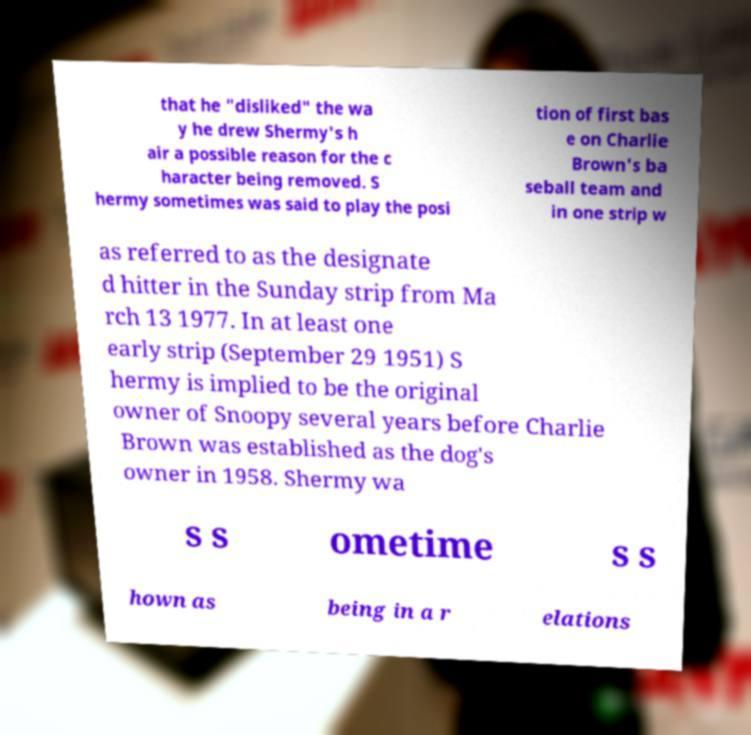There's text embedded in this image that I need extracted. Can you transcribe it verbatim? that he "disliked" the wa y he drew Shermy's h air a possible reason for the c haracter being removed. S hermy sometimes was said to play the posi tion of first bas e on Charlie Brown's ba seball team and in one strip w as referred to as the designate d hitter in the Sunday strip from Ma rch 13 1977. In at least one early strip (September 29 1951) S hermy is implied to be the original owner of Snoopy several years before Charlie Brown was established as the dog's owner in 1958. Shermy wa s s ometime s s hown as being in a r elations 